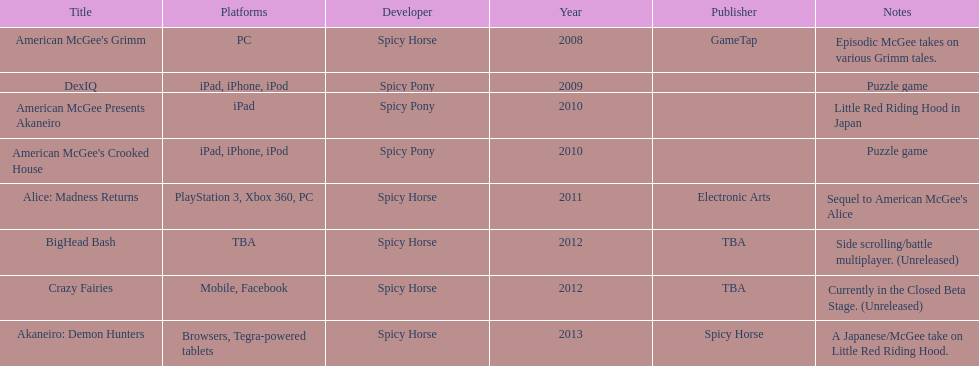What was the only game published by electronic arts? Alice: Madness Returns. 